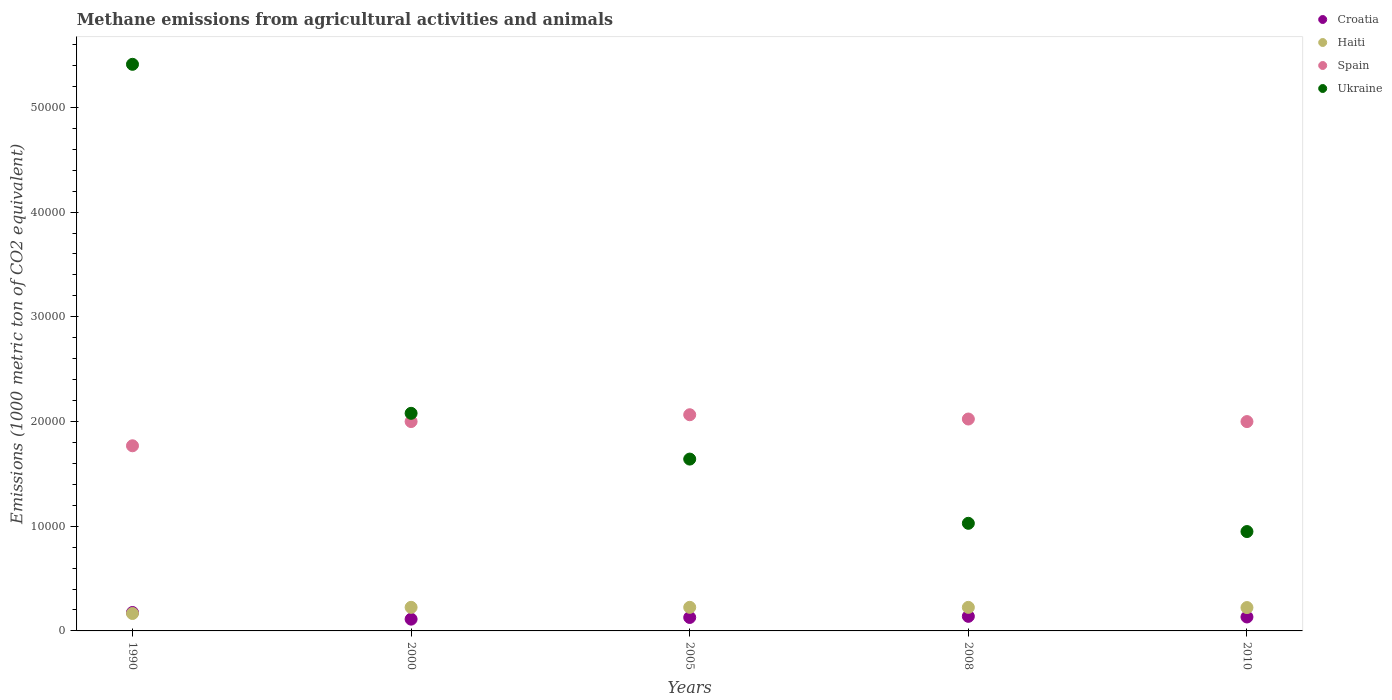Is the number of dotlines equal to the number of legend labels?
Your answer should be very brief. Yes. What is the amount of methane emitted in Spain in 2010?
Provide a succinct answer. 2.00e+04. Across all years, what is the maximum amount of methane emitted in Haiti?
Your response must be concise. 2253. Across all years, what is the minimum amount of methane emitted in Ukraine?
Provide a succinct answer. 9489.8. In which year was the amount of methane emitted in Ukraine minimum?
Give a very brief answer. 2010. What is the total amount of methane emitted in Croatia in the graph?
Your response must be concise. 6892.9. What is the difference between the amount of methane emitted in Haiti in 2005 and that in 2008?
Your answer should be very brief. 3.5. What is the difference between the amount of methane emitted in Ukraine in 2005 and the amount of methane emitted in Croatia in 2000?
Make the answer very short. 1.53e+04. What is the average amount of methane emitted in Croatia per year?
Your response must be concise. 1378.58. In the year 1990, what is the difference between the amount of methane emitted in Haiti and amount of methane emitted in Spain?
Make the answer very short. -1.60e+04. What is the ratio of the amount of methane emitted in Haiti in 2000 to that in 2005?
Offer a terse response. 1. Is the amount of methane emitted in Haiti in 1990 less than that in 2005?
Offer a terse response. Yes. Is the difference between the amount of methane emitted in Haiti in 2000 and 2010 greater than the difference between the amount of methane emitted in Spain in 2000 and 2010?
Your answer should be compact. Yes. What is the difference between the highest and the second highest amount of methane emitted in Spain?
Keep it short and to the point. 408.9. What is the difference between the highest and the lowest amount of methane emitted in Haiti?
Offer a very short reply. 589.1. Is the amount of methane emitted in Ukraine strictly greater than the amount of methane emitted in Croatia over the years?
Provide a succinct answer. Yes. What is the difference between two consecutive major ticks on the Y-axis?
Provide a short and direct response. 10000. Are the values on the major ticks of Y-axis written in scientific E-notation?
Give a very brief answer. No. Does the graph contain any zero values?
Your response must be concise. No. Where does the legend appear in the graph?
Your answer should be compact. Top right. How many legend labels are there?
Offer a very short reply. 4. How are the legend labels stacked?
Give a very brief answer. Vertical. What is the title of the graph?
Give a very brief answer. Methane emissions from agricultural activities and animals. Does "Japan" appear as one of the legend labels in the graph?
Make the answer very short. No. What is the label or title of the Y-axis?
Offer a terse response. Emissions (1000 metric ton of CO2 equivalent). What is the Emissions (1000 metric ton of CO2 equivalent) of Croatia in 1990?
Offer a very short reply. 1759.1. What is the Emissions (1000 metric ton of CO2 equivalent) of Haiti in 1990?
Your answer should be very brief. 1663.9. What is the Emissions (1000 metric ton of CO2 equivalent) in Spain in 1990?
Keep it short and to the point. 1.77e+04. What is the Emissions (1000 metric ton of CO2 equivalent) in Ukraine in 1990?
Your answer should be very brief. 5.41e+04. What is the Emissions (1000 metric ton of CO2 equivalent) in Croatia in 2000?
Ensure brevity in your answer.  1124.5. What is the Emissions (1000 metric ton of CO2 equivalent) in Haiti in 2000?
Offer a terse response. 2252.5. What is the Emissions (1000 metric ton of CO2 equivalent) of Spain in 2000?
Give a very brief answer. 2.00e+04. What is the Emissions (1000 metric ton of CO2 equivalent) of Ukraine in 2000?
Keep it short and to the point. 2.08e+04. What is the Emissions (1000 metric ton of CO2 equivalent) of Croatia in 2005?
Offer a terse response. 1285.2. What is the Emissions (1000 metric ton of CO2 equivalent) in Haiti in 2005?
Your answer should be very brief. 2253. What is the Emissions (1000 metric ton of CO2 equivalent) of Spain in 2005?
Give a very brief answer. 2.06e+04. What is the Emissions (1000 metric ton of CO2 equivalent) in Ukraine in 2005?
Make the answer very short. 1.64e+04. What is the Emissions (1000 metric ton of CO2 equivalent) of Croatia in 2008?
Your answer should be compact. 1392.8. What is the Emissions (1000 metric ton of CO2 equivalent) of Haiti in 2008?
Your answer should be very brief. 2249.5. What is the Emissions (1000 metric ton of CO2 equivalent) in Spain in 2008?
Your response must be concise. 2.02e+04. What is the Emissions (1000 metric ton of CO2 equivalent) of Ukraine in 2008?
Keep it short and to the point. 1.03e+04. What is the Emissions (1000 metric ton of CO2 equivalent) of Croatia in 2010?
Keep it short and to the point. 1331.3. What is the Emissions (1000 metric ton of CO2 equivalent) in Haiti in 2010?
Provide a succinct answer. 2230.5. What is the Emissions (1000 metric ton of CO2 equivalent) of Spain in 2010?
Your response must be concise. 2.00e+04. What is the Emissions (1000 metric ton of CO2 equivalent) in Ukraine in 2010?
Offer a very short reply. 9489.8. Across all years, what is the maximum Emissions (1000 metric ton of CO2 equivalent) in Croatia?
Provide a succinct answer. 1759.1. Across all years, what is the maximum Emissions (1000 metric ton of CO2 equivalent) of Haiti?
Make the answer very short. 2253. Across all years, what is the maximum Emissions (1000 metric ton of CO2 equivalent) in Spain?
Your answer should be very brief. 2.06e+04. Across all years, what is the maximum Emissions (1000 metric ton of CO2 equivalent) of Ukraine?
Provide a short and direct response. 5.41e+04. Across all years, what is the minimum Emissions (1000 metric ton of CO2 equivalent) in Croatia?
Make the answer very short. 1124.5. Across all years, what is the minimum Emissions (1000 metric ton of CO2 equivalent) in Haiti?
Ensure brevity in your answer.  1663.9. Across all years, what is the minimum Emissions (1000 metric ton of CO2 equivalent) of Spain?
Offer a very short reply. 1.77e+04. Across all years, what is the minimum Emissions (1000 metric ton of CO2 equivalent) in Ukraine?
Keep it short and to the point. 9489.8. What is the total Emissions (1000 metric ton of CO2 equivalent) in Croatia in the graph?
Your answer should be very brief. 6892.9. What is the total Emissions (1000 metric ton of CO2 equivalent) in Haiti in the graph?
Your answer should be very brief. 1.06e+04. What is the total Emissions (1000 metric ton of CO2 equivalent) in Spain in the graph?
Ensure brevity in your answer.  9.86e+04. What is the total Emissions (1000 metric ton of CO2 equivalent) in Ukraine in the graph?
Ensure brevity in your answer.  1.11e+05. What is the difference between the Emissions (1000 metric ton of CO2 equivalent) in Croatia in 1990 and that in 2000?
Offer a terse response. 634.6. What is the difference between the Emissions (1000 metric ton of CO2 equivalent) in Haiti in 1990 and that in 2000?
Ensure brevity in your answer.  -588.6. What is the difference between the Emissions (1000 metric ton of CO2 equivalent) of Spain in 1990 and that in 2000?
Offer a terse response. -2314.1. What is the difference between the Emissions (1000 metric ton of CO2 equivalent) of Ukraine in 1990 and that in 2000?
Offer a terse response. 3.33e+04. What is the difference between the Emissions (1000 metric ton of CO2 equivalent) of Croatia in 1990 and that in 2005?
Your answer should be very brief. 473.9. What is the difference between the Emissions (1000 metric ton of CO2 equivalent) in Haiti in 1990 and that in 2005?
Your answer should be very brief. -589.1. What is the difference between the Emissions (1000 metric ton of CO2 equivalent) of Spain in 1990 and that in 2005?
Offer a terse response. -2964.8. What is the difference between the Emissions (1000 metric ton of CO2 equivalent) of Ukraine in 1990 and that in 2005?
Give a very brief answer. 3.77e+04. What is the difference between the Emissions (1000 metric ton of CO2 equivalent) of Croatia in 1990 and that in 2008?
Provide a short and direct response. 366.3. What is the difference between the Emissions (1000 metric ton of CO2 equivalent) of Haiti in 1990 and that in 2008?
Provide a succinct answer. -585.6. What is the difference between the Emissions (1000 metric ton of CO2 equivalent) of Spain in 1990 and that in 2008?
Offer a very short reply. -2555.9. What is the difference between the Emissions (1000 metric ton of CO2 equivalent) of Ukraine in 1990 and that in 2008?
Offer a terse response. 4.38e+04. What is the difference between the Emissions (1000 metric ton of CO2 equivalent) in Croatia in 1990 and that in 2010?
Your answer should be compact. 427.8. What is the difference between the Emissions (1000 metric ton of CO2 equivalent) of Haiti in 1990 and that in 2010?
Keep it short and to the point. -566.6. What is the difference between the Emissions (1000 metric ton of CO2 equivalent) in Spain in 1990 and that in 2010?
Make the answer very short. -2311. What is the difference between the Emissions (1000 metric ton of CO2 equivalent) in Ukraine in 1990 and that in 2010?
Make the answer very short. 4.46e+04. What is the difference between the Emissions (1000 metric ton of CO2 equivalent) of Croatia in 2000 and that in 2005?
Keep it short and to the point. -160.7. What is the difference between the Emissions (1000 metric ton of CO2 equivalent) of Spain in 2000 and that in 2005?
Keep it short and to the point. -650.7. What is the difference between the Emissions (1000 metric ton of CO2 equivalent) of Ukraine in 2000 and that in 2005?
Ensure brevity in your answer.  4372.1. What is the difference between the Emissions (1000 metric ton of CO2 equivalent) in Croatia in 2000 and that in 2008?
Keep it short and to the point. -268.3. What is the difference between the Emissions (1000 metric ton of CO2 equivalent) in Spain in 2000 and that in 2008?
Your answer should be compact. -241.8. What is the difference between the Emissions (1000 metric ton of CO2 equivalent) in Ukraine in 2000 and that in 2008?
Keep it short and to the point. 1.05e+04. What is the difference between the Emissions (1000 metric ton of CO2 equivalent) of Croatia in 2000 and that in 2010?
Offer a very short reply. -206.8. What is the difference between the Emissions (1000 metric ton of CO2 equivalent) of Haiti in 2000 and that in 2010?
Keep it short and to the point. 22. What is the difference between the Emissions (1000 metric ton of CO2 equivalent) of Ukraine in 2000 and that in 2010?
Your answer should be compact. 1.13e+04. What is the difference between the Emissions (1000 metric ton of CO2 equivalent) in Croatia in 2005 and that in 2008?
Your answer should be very brief. -107.6. What is the difference between the Emissions (1000 metric ton of CO2 equivalent) in Haiti in 2005 and that in 2008?
Offer a very short reply. 3.5. What is the difference between the Emissions (1000 metric ton of CO2 equivalent) of Spain in 2005 and that in 2008?
Give a very brief answer. 408.9. What is the difference between the Emissions (1000 metric ton of CO2 equivalent) in Ukraine in 2005 and that in 2008?
Provide a succinct answer. 6133.4. What is the difference between the Emissions (1000 metric ton of CO2 equivalent) in Croatia in 2005 and that in 2010?
Keep it short and to the point. -46.1. What is the difference between the Emissions (1000 metric ton of CO2 equivalent) of Spain in 2005 and that in 2010?
Keep it short and to the point. 653.8. What is the difference between the Emissions (1000 metric ton of CO2 equivalent) of Ukraine in 2005 and that in 2010?
Offer a terse response. 6921.6. What is the difference between the Emissions (1000 metric ton of CO2 equivalent) of Croatia in 2008 and that in 2010?
Offer a terse response. 61.5. What is the difference between the Emissions (1000 metric ton of CO2 equivalent) of Haiti in 2008 and that in 2010?
Keep it short and to the point. 19. What is the difference between the Emissions (1000 metric ton of CO2 equivalent) in Spain in 2008 and that in 2010?
Ensure brevity in your answer.  244.9. What is the difference between the Emissions (1000 metric ton of CO2 equivalent) in Ukraine in 2008 and that in 2010?
Ensure brevity in your answer.  788.2. What is the difference between the Emissions (1000 metric ton of CO2 equivalent) in Croatia in 1990 and the Emissions (1000 metric ton of CO2 equivalent) in Haiti in 2000?
Offer a terse response. -493.4. What is the difference between the Emissions (1000 metric ton of CO2 equivalent) of Croatia in 1990 and the Emissions (1000 metric ton of CO2 equivalent) of Spain in 2000?
Provide a succinct answer. -1.82e+04. What is the difference between the Emissions (1000 metric ton of CO2 equivalent) of Croatia in 1990 and the Emissions (1000 metric ton of CO2 equivalent) of Ukraine in 2000?
Provide a succinct answer. -1.90e+04. What is the difference between the Emissions (1000 metric ton of CO2 equivalent) of Haiti in 1990 and the Emissions (1000 metric ton of CO2 equivalent) of Spain in 2000?
Offer a very short reply. -1.83e+04. What is the difference between the Emissions (1000 metric ton of CO2 equivalent) of Haiti in 1990 and the Emissions (1000 metric ton of CO2 equivalent) of Ukraine in 2000?
Give a very brief answer. -1.91e+04. What is the difference between the Emissions (1000 metric ton of CO2 equivalent) of Spain in 1990 and the Emissions (1000 metric ton of CO2 equivalent) of Ukraine in 2000?
Ensure brevity in your answer.  -3100.9. What is the difference between the Emissions (1000 metric ton of CO2 equivalent) in Croatia in 1990 and the Emissions (1000 metric ton of CO2 equivalent) in Haiti in 2005?
Offer a very short reply. -493.9. What is the difference between the Emissions (1000 metric ton of CO2 equivalent) of Croatia in 1990 and the Emissions (1000 metric ton of CO2 equivalent) of Spain in 2005?
Provide a short and direct response. -1.89e+04. What is the difference between the Emissions (1000 metric ton of CO2 equivalent) in Croatia in 1990 and the Emissions (1000 metric ton of CO2 equivalent) in Ukraine in 2005?
Keep it short and to the point. -1.47e+04. What is the difference between the Emissions (1000 metric ton of CO2 equivalent) of Haiti in 1990 and the Emissions (1000 metric ton of CO2 equivalent) of Spain in 2005?
Your response must be concise. -1.90e+04. What is the difference between the Emissions (1000 metric ton of CO2 equivalent) of Haiti in 1990 and the Emissions (1000 metric ton of CO2 equivalent) of Ukraine in 2005?
Ensure brevity in your answer.  -1.47e+04. What is the difference between the Emissions (1000 metric ton of CO2 equivalent) in Spain in 1990 and the Emissions (1000 metric ton of CO2 equivalent) in Ukraine in 2005?
Provide a succinct answer. 1271.2. What is the difference between the Emissions (1000 metric ton of CO2 equivalent) in Croatia in 1990 and the Emissions (1000 metric ton of CO2 equivalent) in Haiti in 2008?
Make the answer very short. -490.4. What is the difference between the Emissions (1000 metric ton of CO2 equivalent) in Croatia in 1990 and the Emissions (1000 metric ton of CO2 equivalent) in Spain in 2008?
Your answer should be compact. -1.85e+04. What is the difference between the Emissions (1000 metric ton of CO2 equivalent) of Croatia in 1990 and the Emissions (1000 metric ton of CO2 equivalent) of Ukraine in 2008?
Provide a short and direct response. -8518.9. What is the difference between the Emissions (1000 metric ton of CO2 equivalent) in Haiti in 1990 and the Emissions (1000 metric ton of CO2 equivalent) in Spain in 2008?
Keep it short and to the point. -1.86e+04. What is the difference between the Emissions (1000 metric ton of CO2 equivalent) of Haiti in 1990 and the Emissions (1000 metric ton of CO2 equivalent) of Ukraine in 2008?
Offer a terse response. -8614.1. What is the difference between the Emissions (1000 metric ton of CO2 equivalent) of Spain in 1990 and the Emissions (1000 metric ton of CO2 equivalent) of Ukraine in 2008?
Your answer should be very brief. 7404.6. What is the difference between the Emissions (1000 metric ton of CO2 equivalent) of Croatia in 1990 and the Emissions (1000 metric ton of CO2 equivalent) of Haiti in 2010?
Offer a very short reply. -471.4. What is the difference between the Emissions (1000 metric ton of CO2 equivalent) in Croatia in 1990 and the Emissions (1000 metric ton of CO2 equivalent) in Spain in 2010?
Ensure brevity in your answer.  -1.82e+04. What is the difference between the Emissions (1000 metric ton of CO2 equivalent) in Croatia in 1990 and the Emissions (1000 metric ton of CO2 equivalent) in Ukraine in 2010?
Keep it short and to the point. -7730.7. What is the difference between the Emissions (1000 metric ton of CO2 equivalent) in Haiti in 1990 and the Emissions (1000 metric ton of CO2 equivalent) in Spain in 2010?
Offer a terse response. -1.83e+04. What is the difference between the Emissions (1000 metric ton of CO2 equivalent) of Haiti in 1990 and the Emissions (1000 metric ton of CO2 equivalent) of Ukraine in 2010?
Your answer should be compact. -7825.9. What is the difference between the Emissions (1000 metric ton of CO2 equivalent) of Spain in 1990 and the Emissions (1000 metric ton of CO2 equivalent) of Ukraine in 2010?
Provide a short and direct response. 8192.8. What is the difference between the Emissions (1000 metric ton of CO2 equivalent) in Croatia in 2000 and the Emissions (1000 metric ton of CO2 equivalent) in Haiti in 2005?
Provide a succinct answer. -1128.5. What is the difference between the Emissions (1000 metric ton of CO2 equivalent) of Croatia in 2000 and the Emissions (1000 metric ton of CO2 equivalent) of Spain in 2005?
Make the answer very short. -1.95e+04. What is the difference between the Emissions (1000 metric ton of CO2 equivalent) in Croatia in 2000 and the Emissions (1000 metric ton of CO2 equivalent) in Ukraine in 2005?
Your answer should be compact. -1.53e+04. What is the difference between the Emissions (1000 metric ton of CO2 equivalent) in Haiti in 2000 and the Emissions (1000 metric ton of CO2 equivalent) in Spain in 2005?
Offer a terse response. -1.84e+04. What is the difference between the Emissions (1000 metric ton of CO2 equivalent) of Haiti in 2000 and the Emissions (1000 metric ton of CO2 equivalent) of Ukraine in 2005?
Give a very brief answer. -1.42e+04. What is the difference between the Emissions (1000 metric ton of CO2 equivalent) of Spain in 2000 and the Emissions (1000 metric ton of CO2 equivalent) of Ukraine in 2005?
Keep it short and to the point. 3585.3. What is the difference between the Emissions (1000 metric ton of CO2 equivalent) of Croatia in 2000 and the Emissions (1000 metric ton of CO2 equivalent) of Haiti in 2008?
Your answer should be compact. -1125. What is the difference between the Emissions (1000 metric ton of CO2 equivalent) in Croatia in 2000 and the Emissions (1000 metric ton of CO2 equivalent) in Spain in 2008?
Give a very brief answer. -1.91e+04. What is the difference between the Emissions (1000 metric ton of CO2 equivalent) of Croatia in 2000 and the Emissions (1000 metric ton of CO2 equivalent) of Ukraine in 2008?
Make the answer very short. -9153.5. What is the difference between the Emissions (1000 metric ton of CO2 equivalent) of Haiti in 2000 and the Emissions (1000 metric ton of CO2 equivalent) of Spain in 2008?
Give a very brief answer. -1.80e+04. What is the difference between the Emissions (1000 metric ton of CO2 equivalent) of Haiti in 2000 and the Emissions (1000 metric ton of CO2 equivalent) of Ukraine in 2008?
Ensure brevity in your answer.  -8025.5. What is the difference between the Emissions (1000 metric ton of CO2 equivalent) of Spain in 2000 and the Emissions (1000 metric ton of CO2 equivalent) of Ukraine in 2008?
Provide a short and direct response. 9718.7. What is the difference between the Emissions (1000 metric ton of CO2 equivalent) of Croatia in 2000 and the Emissions (1000 metric ton of CO2 equivalent) of Haiti in 2010?
Keep it short and to the point. -1106. What is the difference between the Emissions (1000 metric ton of CO2 equivalent) of Croatia in 2000 and the Emissions (1000 metric ton of CO2 equivalent) of Spain in 2010?
Provide a short and direct response. -1.89e+04. What is the difference between the Emissions (1000 metric ton of CO2 equivalent) of Croatia in 2000 and the Emissions (1000 metric ton of CO2 equivalent) of Ukraine in 2010?
Offer a very short reply. -8365.3. What is the difference between the Emissions (1000 metric ton of CO2 equivalent) of Haiti in 2000 and the Emissions (1000 metric ton of CO2 equivalent) of Spain in 2010?
Offer a terse response. -1.77e+04. What is the difference between the Emissions (1000 metric ton of CO2 equivalent) in Haiti in 2000 and the Emissions (1000 metric ton of CO2 equivalent) in Ukraine in 2010?
Provide a short and direct response. -7237.3. What is the difference between the Emissions (1000 metric ton of CO2 equivalent) in Spain in 2000 and the Emissions (1000 metric ton of CO2 equivalent) in Ukraine in 2010?
Offer a terse response. 1.05e+04. What is the difference between the Emissions (1000 metric ton of CO2 equivalent) of Croatia in 2005 and the Emissions (1000 metric ton of CO2 equivalent) of Haiti in 2008?
Give a very brief answer. -964.3. What is the difference between the Emissions (1000 metric ton of CO2 equivalent) in Croatia in 2005 and the Emissions (1000 metric ton of CO2 equivalent) in Spain in 2008?
Your answer should be compact. -1.90e+04. What is the difference between the Emissions (1000 metric ton of CO2 equivalent) of Croatia in 2005 and the Emissions (1000 metric ton of CO2 equivalent) of Ukraine in 2008?
Provide a succinct answer. -8992.8. What is the difference between the Emissions (1000 metric ton of CO2 equivalent) in Haiti in 2005 and the Emissions (1000 metric ton of CO2 equivalent) in Spain in 2008?
Your answer should be compact. -1.80e+04. What is the difference between the Emissions (1000 metric ton of CO2 equivalent) in Haiti in 2005 and the Emissions (1000 metric ton of CO2 equivalent) in Ukraine in 2008?
Your response must be concise. -8025. What is the difference between the Emissions (1000 metric ton of CO2 equivalent) in Spain in 2005 and the Emissions (1000 metric ton of CO2 equivalent) in Ukraine in 2008?
Your response must be concise. 1.04e+04. What is the difference between the Emissions (1000 metric ton of CO2 equivalent) of Croatia in 2005 and the Emissions (1000 metric ton of CO2 equivalent) of Haiti in 2010?
Give a very brief answer. -945.3. What is the difference between the Emissions (1000 metric ton of CO2 equivalent) in Croatia in 2005 and the Emissions (1000 metric ton of CO2 equivalent) in Spain in 2010?
Your answer should be compact. -1.87e+04. What is the difference between the Emissions (1000 metric ton of CO2 equivalent) in Croatia in 2005 and the Emissions (1000 metric ton of CO2 equivalent) in Ukraine in 2010?
Your answer should be compact. -8204.6. What is the difference between the Emissions (1000 metric ton of CO2 equivalent) of Haiti in 2005 and the Emissions (1000 metric ton of CO2 equivalent) of Spain in 2010?
Your response must be concise. -1.77e+04. What is the difference between the Emissions (1000 metric ton of CO2 equivalent) in Haiti in 2005 and the Emissions (1000 metric ton of CO2 equivalent) in Ukraine in 2010?
Provide a short and direct response. -7236.8. What is the difference between the Emissions (1000 metric ton of CO2 equivalent) of Spain in 2005 and the Emissions (1000 metric ton of CO2 equivalent) of Ukraine in 2010?
Provide a succinct answer. 1.12e+04. What is the difference between the Emissions (1000 metric ton of CO2 equivalent) of Croatia in 2008 and the Emissions (1000 metric ton of CO2 equivalent) of Haiti in 2010?
Give a very brief answer. -837.7. What is the difference between the Emissions (1000 metric ton of CO2 equivalent) in Croatia in 2008 and the Emissions (1000 metric ton of CO2 equivalent) in Spain in 2010?
Your answer should be compact. -1.86e+04. What is the difference between the Emissions (1000 metric ton of CO2 equivalent) of Croatia in 2008 and the Emissions (1000 metric ton of CO2 equivalent) of Ukraine in 2010?
Provide a succinct answer. -8097. What is the difference between the Emissions (1000 metric ton of CO2 equivalent) in Haiti in 2008 and the Emissions (1000 metric ton of CO2 equivalent) in Spain in 2010?
Offer a terse response. -1.77e+04. What is the difference between the Emissions (1000 metric ton of CO2 equivalent) in Haiti in 2008 and the Emissions (1000 metric ton of CO2 equivalent) in Ukraine in 2010?
Your response must be concise. -7240.3. What is the difference between the Emissions (1000 metric ton of CO2 equivalent) of Spain in 2008 and the Emissions (1000 metric ton of CO2 equivalent) of Ukraine in 2010?
Give a very brief answer. 1.07e+04. What is the average Emissions (1000 metric ton of CO2 equivalent) in Croatia per year?
Ensure brevity in your answer.  1378.58. What is the average Emissions (1000 metric ton of CO2 equivalent) of Haiti per year?
Your answer should be compact. 2129.88. What is the average Emissions (1000 metric ton of CO2 equivalent) of Spain per year?
Give a very brief answer. 1.97e+04. What is the average Emissions (1000 metric ton of CO2 equivalent) in Ukraine per year?
Keep it short and to the point. 2.22e+04. In the year 1990, what is the difference between the Emissions (1000 metric ton of CO2 equivalent) in Croatia and Emissions (1000 metric ton of CO2 equivalent) in Haiti?
Offer a very short reply. 95.2. In the year 1990, what is the difference between the Emissions (1000 metric ton of CO2 equivalent) of Croatia and Emissions (1000 metric ton of CO2 equivalent) of Spain?
Your response must be concise. -1.59e+04. In the year 1990, what is the difference between the Emissions (1000 metric ton of CO2 equivalent) in Croatia and Emissions (1000 metric ton of CO2 equivalent) in Ukraine?
Keep it short and to the point. -5.24e+04. In the year 1990, what is the difference between the Emissions (1000 metric ton of CO2 equivalent) of Haiti and Emissions (1000 metric ton of CO2 equivalent) of Spain?
Your answer should be compact. -1.60e+04. In the year 1990, what is the difference between the Emissions (1000 metric ton of CO2 equivalent) of Haiti and Emissions (1000 metric ton of CO2 equivalent) of Ukraine?
Provide a short and direct response. -5.25e+04. In the year 1990, what is the difference between the Emissions (1000 metric ton of CO2 equivalent) of Spain and Emissions (1000 metric ton of CO2 equivalent) of Ukraine?
Your answer should be very brief. -3.64e+04. In the year 2000, what is the difference between the Emissions (1000 metric ton of CO2 equivalent) in Croatia and Emissions (1000 metric ton of CO2 equivalent) in Haiti?
Your answer should be very brief. -1128. In the year 2000, what is the difference between the Emissions (1000 metric ton of CO2 equivalent) of Croatia and Emissions (1000 metric ton of CO2 equivalent) of Spain?
Keep it short and to the point. -1.89e+04. In the year 2000, what is the difference between the Emissions (1000 metric ton of CO2 equivalent) of Croatia and Emissions (1000 metric ton of CO2 equivalent) of Ukraine?
Your answer should be very brief. -1.97e+04. In the year 2000, what is the difference between the Emissions (1000 metric ton of CO2 equivalent) in Haiti and Emissions (1000 metric ton of CO2 equivalent) in Spain?
Give a very brief answer. -1.77e+04. In the year 2000, what is the difference between the Emissions (1000 metric ton of CO2 equivalent) of Haiti and Emissions (1000 metric ton of CO2 equivalent) of Ukraine?
Offer a very short reply. -1.85e+04. In the year 2000, what is the difference between the Emissions (1000 metric ton of CO2 equivalent) of Spain and Emissions (1000 metric ton of CO2 equivalent) of Ukraine?
Ensure brevity in your answer.  -786.8. In the year 2005, what is the difference between the Emissions (1000 metric ton of CO2 equivalent) in Croatia and Emissions (1000 metric ton of CO2 equivalent) in Haiti?
Your answer should be compact. -967.8. In the year 2005, what is the difference between the Emissions (1000 metric ton of CO2 equivalent) in Croatia and Emissions (1000 metric ton of CO2 equivalent) in Spain?
Your answer should be very brief. -1.94e+04. In the year 2005, what is the difference between the Emissions (1000 metric ton of CO2 equivalent) of Croatia and Emissions (1000 metric ton of CO2 equivalent) of Ukraine?
Offer a terse response. -1.51e+04. In the year 2005, what is the difference between the Emissions (1000 metric ton of CO2 equivalent) of Haiti and Emissions (1000 metric ton of CO2 equivalent) of Spain?
Offer a terse response. -1.84e+04. In the year 2005, what is the difference between the Emissions (1000 metric ton of CO2 equivalent) in Haiti and Emissions (1000 metric ton of CO2 equivalent) in Ukraine?
Ensure brevity in your answer.  -1.42e+04. In the year 2005, what is the difference between the Emissions (1000 metric ton of CO2 equivalent) of Spain and Emissions (1000 metric ton of CO2 equivalent) of Ukraine?
Offer a very short reply. 4236. In the year 2008, what is the difference between the Emissions (1000 metric ton of CO2 equivalent) in Croatia and Emissions (1000 metric ton of CO2 equivalent) in Haiti?
Provide a short and direct response. -856.7. In the year 2008, what is the difference between the Emissions (1000 metric ton of CO2 equivalent) in Croatia and Emissions (1000 metric ton of CO2 equivalent) in Spain?
Provide a short and direct response. -1.88e+04. In the year 2008, what is the difference between the Emissions (1000 metric ton of CO2 equivalent) in Croatia and Emissions (1000 metric ton of CO2 equivalent) in Ukraine?
Make the answer very short. -8885.2. In the year 2008, what is the difference between the Emissions (1000 metric ton of CO2 equivalent) of Haiti and Emissions (1000 metric ton of CO2 equivalent) of Spain?
Give a very brief answer. -1.80e+04. In the year 2008, what is the difference between the Emissions (1000 metric ton of CO2 equivalent) of Haiti and Emissions (1000 metric ton of CO2 equivalent) of Ukraine?
Your answer should be very brief. -8028.5. In the year 2008, what is the difference between the Emissions (1000 metric ton of CO2 equivalent) in Spain and Emissions (1000 metric ton of CO2 equivalent) in Ukraine?
Offer a terse response. 9960.5. In the year 2010, what is the difference between the Emissions (1000 metric ton of CO2 equivalent) of Croatia and Emissions (1000 metric ton of CO2 equivalent) of Haiti?
Offer a terse response. -899.2. In the year 2010, what is the difference between the Emissions (1000 metric ton of CO2 equivalent) in Croatia and Emissions (1000 metric ton of CO2 equivalent) in Spain?
Provide a short and direct response. -1.87e+04. In the year 2010, what is the difference between the Emissions (1000 metric ton of CO2 equivalent) of Croatia and Emissions (1000 metric ton of CO2 equivalent) of Ukraine?
Ensure brevity in your answer.  -8158.5. In the year 2010, what is the difference between the Emissions (1000 metric ton of CO2 equivalent) in Haiti and Emissions (1000 metric ton of CO2 equivalent) in Spain?
Provide a succinct answer. -1.78e+04. In the year 2010, what is the difference between the Emissions (1000 metric ton of CO2 equivalent) of Haiti and Emissions (1000 metric ton of CO2 equivalent) of Ukraine?
Provide a short and direct response. -7259.3. In the year 2010, what is the difference between the Emissions (1000 metric ton of CO2 equivalent) of Spain and Emissions (1000 metric ton of CO2 equivalent) of Ukraine?
Offer a very short reply. 1.05e+04. What is the ratio of the Emissions (1000 metric ton of CO2 equivalent) of Croatia in 1990 to that in 2000?
Provide a succinct answer. 1.56. What is the ratio of the Emissions (1000 metric ton of CO2 equivalent) in Haiti in 1990 to that in 2000?
Ensure brevity in your answer.  0.74. What is the ratio of the Emissions (1000 metric ton of CO2 equivalent) in Spain in 1990 to that in 2000?
Your response must be concise. 0.88. What is the ratio of the Emissions (1000 metric ton of CO2 equivalent) in Ukraine in 1990 to that in 2000?
Offer a terse response. 2.6. What is the ratio of the Emissions (1000 metric ton of CO2 equivalent) of Croatia in 1990 to that in 2005?
Ensure brevity in your answer.  1.37. What is the ratio of the Emissions (1000 metric ton of CO2 equivalent) of Haiti in 1990 to that in 2005?
Your response must be concise. 0.74. What is the ratio of the Emissions (1000 metric ton of CO2 equivalent) in Spain in 1990 to that in 2005?
Your answer should be compact. 0.86. What is the ratio of the Emissions (1000 metric ton of CO2 equivalent) in Ukraine in 1990 to that in 2005?
Ensure brevity in your answer.  3.3. What is the ratio of the Emissions (1000 metric ton of CO2 equivalent) in Croatia in 1990 to that in 2008?
Your response must be concise. 1.26. What is the ratio of the Emissions (1000 metric ton of CO2 equivalent) of Haiti in 1990 to that in 2008?
Keep it short and to the point. 0.74. What is the ratio of the Emissions (1000 metric ton of CO2 equivalent) in Spain in 1990 to that in 2008?
Make the answer very short. 0.87. What is the ratio of the Emissions (1000 metric ton of CO2 equivalent) of Ukraine in 1990 to that in 2008?
Keep it short and to the point. 5.27. What is the ratio of the Emissions (1000 metric ton of CO2 equivalent) of Croatia in 1990 to that in 2010?
Your response must be concise. 1.32. What is the ratio of the Emissions (1000 metric ton of CO2 equivalent) of Haiti in 1990 to that in 2010?
Provide a short and direct response. 0.75. What is the ratio of the Emissions (1000 metric ton of CO2 equivalent) in Spain in 1990 to that in 2010?
Offer a terse response. 0.88. What is the ratio of the Emissions (1000 metric ton of CO2 equivalent) of Ukraine in 1990 to that in 2010?
Make the answer very short. 5.7. What is the ratio of the Emissions (1000 metric ton of CO2 equivalent) in Haiti in 2000 to that in 2005?
Keep it short and to the point. 1. What is the ratio of the Emissions (1000 metric ton of CO2 equivalent) in Spain in 2000 to that in 2005?
Your answer should be very brief. 0.97. What is the ratio of the Emissions (1000 metric ton of CO2 equivalent) of Ukraine in 2000 to that in 2005?
Keep it short and to the point. 1.27. What is the ratio of the Emissions (1000 metric ton of CO2 equivalent) of Croatia in 2000 to that in 2008?
Keep it short and to the point. 0.81. What is the ratio of the Emissions (1000 metric ton of CO2 equivalent) of Ukraine in 2000 to that in 2008?
Your answer should be very brief. 2.02. What is the ratio of the Emissions (1000 metric ton of CO2 equivalent) in Croatia in 2000 to that in 2010?
Give a very brief answer. 0.84. What is the ratio of the Emissions (1000 metric ton of CO2 equivalent) of Haiti in 2000 to that in 2010?
Ensure brevity in your answer.  1.01. What is the ratio of the Emissions (1000 metric ton of CO2 equivalent) of Spain in 2000 to that in 2010?
Ensure brevity in your answer.  1. What is the ratio of the Emissions (1000 metric ton of CO2 equivalent) of Ukraine in 2000 to that in 2010?
Offer a terse response. 2.19. What is the ratio of the Emissions (1000 metric ton of CO2 equivalent) in Croatia in 2005 to that in 2008?
Ensure brevity in your answer.  0.92. What is the ratio of the Emissions (1000 metric ton of CO2 equivalent) of Haiti in 2005 to that in 2008?
Keep it short and to the point. 1. What is the ratio of the Emissions (1000 metric ton of CO2 equivalent) of Spain in 2005 to that in 2008?
Provide a succinct answer. 1.02. What is the ratio of the Emissions (1000 metric ton of CO2 equivalent) in Ukraine in 2005 to that in 2008?
Offer a terse response. 1.6. What is the ratio of the Emissions (1000 metric ton of CO2 equivalent) of Croatia in 2005 to that in 2010?
Offer a terse response. 0.97. What is the ratio of the Emissions (1000 metric ton of CO2 equivalent) in Haiti in 2005 to that in 2010?
Make the answer very short. 1.01. What is the ratio of the Emissions (1000 metric ton of CO2 equivalent) in Spain in 2005 to that in 2010?
Keep it short and to the point. 1.03. What is the ratio of the Emissions (1000 metric ton of CO2 equivalent) in Ukraine in 2005 to that in 2010?
Your answer should be very brief. 1.73. What is the ratio of the Emissions (1000 metric ton of CO2 equivalent) in Croatia in 2008 to that in 2010?
Make the answer very short. 1.05. What is the ratio of the Emissions (1000 metric ton of CO2 equivalent) of Haiti in 2008 to that in 2010?
Keep it short and to the point. 1.01. What is the ratio of the Emissions (1000 metric ton of CO2 equivalent) of Spain in 2008 to that in 2010?
Offer a very short reply. 1.01. What is the ratio of the Emissions (1000 metric ton of CO2 equivalent) of Ukraine in 2008 to that in 2010?
Give a very brief answer. 1.08. What is the difference between the highest and the second highest Emissions (1000 metric ton of CO2 equivalent) of Croatia?
Offer a very short reply. 366.3. What is the difference between the highest and the second highest Emissions (1000 metric ton of CO2 equivalent) of Spain?
Your answer should be very brief. 408.9. What is the difference between the highest and the second highest Emissions (1000 metric ton of CO2 equivalent) of Ukraine?
Keep it short and to the point. 3.33e+04. What is the difference between the highest and the lowest Emissions (1000 metric ton of CO2 equivalent) of Croatia?
Your answer should be compact. 634.6. What is the difference between the highest and the lowest Emissions (1000 metric ton of CO2 equivalent) in Haiti?
Your response must be concise. 589.1. What is the difference between the highest and the lowest Emissions (1000 metric ton of CO2 equivalent) in Spain?
Keep it short and to the point. 2964.8. What is the difference between the highest and the lowest Emissions (1000 metric ton of CO2 equivalent) in Ukraine?
Your answer should be very brief. 4.46e+04. 